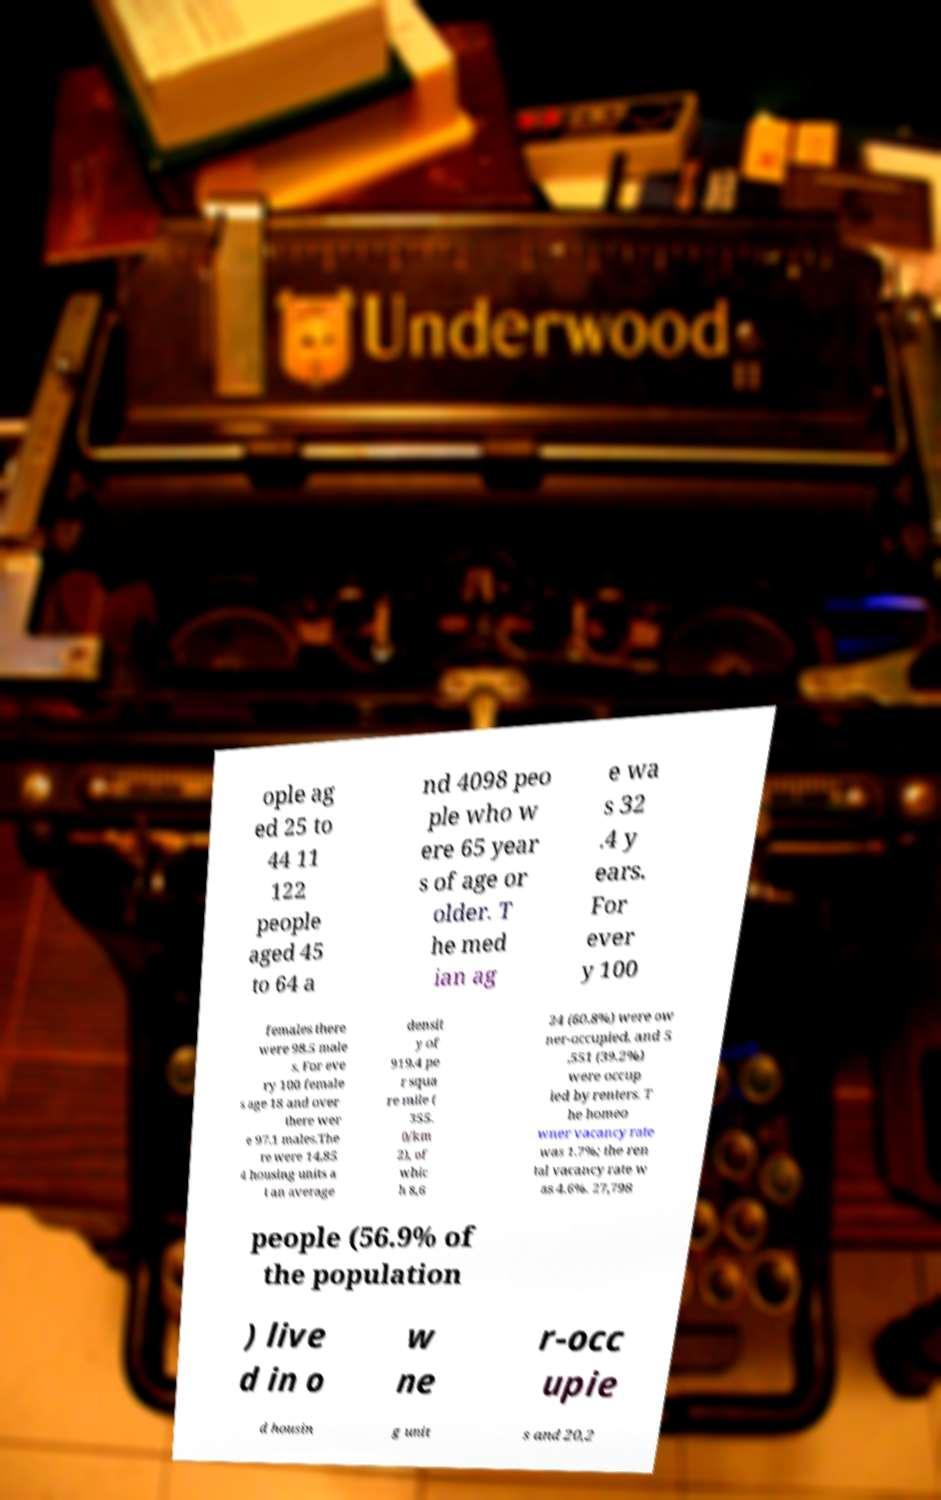Please identify and transcribe the text found in this image. ople ag ed 25 to 44 11 122 people aged 45 to 64 a nd 4098 peo ple who w ere 65 year s of age or older. T he med ian ag e wa s 32 .4 y ears. For ever y 100 females there were 98.5 male s. For eve ry 100 female s age 18 and over there wer e 97.1 males.The re were 14,85 4 housing units a t an average densit y of 919.4 pe r squa re mile ( 355. 0/km 2), of whic h 8,6 24 (60.8%) were ow ner-occupied, and 5 ,551 (39.2%) were occup ied by renters. T he homeo wner vacancy rate was 1.7%; the ren tal vacancy rate w as 4.6%. 27,798 people (56.9% of the population ) live d in o w ne r-occ upie d housin g unit s and 20,2 